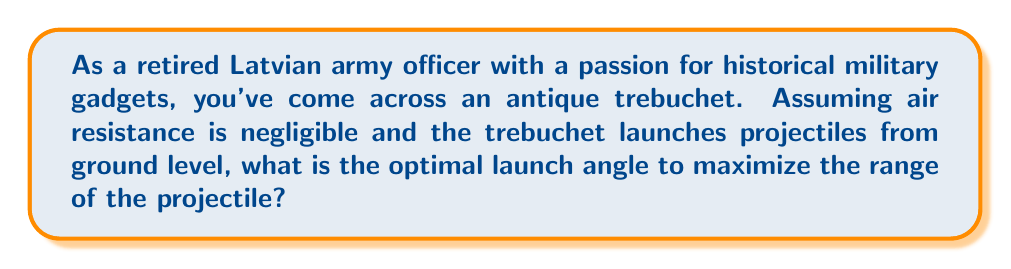Help me with this question. Let's approach this step-by-step:

1) The range of a projectile launched from ground level is given by the equation:

   $$R = \frac{v_0^2 \sin(2\theta)}{g}$$

   Where:
   $R$ is the range
   $v_0$ is the initial velocity
   $\theta$ is the launch angle
   $g$ is the acceleration due to gravity

2) To maximize the range, we need to maximize $\sin(2\theta)$.

3) The sine function reaches its maximum value of 1 when its argument is 90°.

4) So, we want:

   $$2\theta = 90°$$

5) Solving for $\theta$:

   $$\theta = 45°$$

6) We can verify this mathematically by taking the derivative of the range equation with respect to $\theta$ and setting it to zero:

   $$\frac{dR}{d\theta} = \frac{v_0^2}{g} \cdot 2\cos(2\theta) = 0$$

7) This equation is satisfied when $\cos(2\theta) = 0$, which occurs when $2\theta = 90°$, confirming our result.

[asy]
import geometry;

size(200);
draw((-1,0)--(5,0),arrow=Arrow(TeXHead));
draw((0,-0.5)--(0,3),arrow=Arrow(TeXHead));
draw((0,0)--(3,3),arrow=Arrow(TeXHead));

label("x", (5,-0.3));
label("y", (-0.3,3));
label("v₀", (1.7,1.7), NE);

draw(arc((0,0),0.7,0,45),arrow=Arrow(TeXHead));
label("45°", (0.5,0.3));

[/asy]
Answer: 45° 